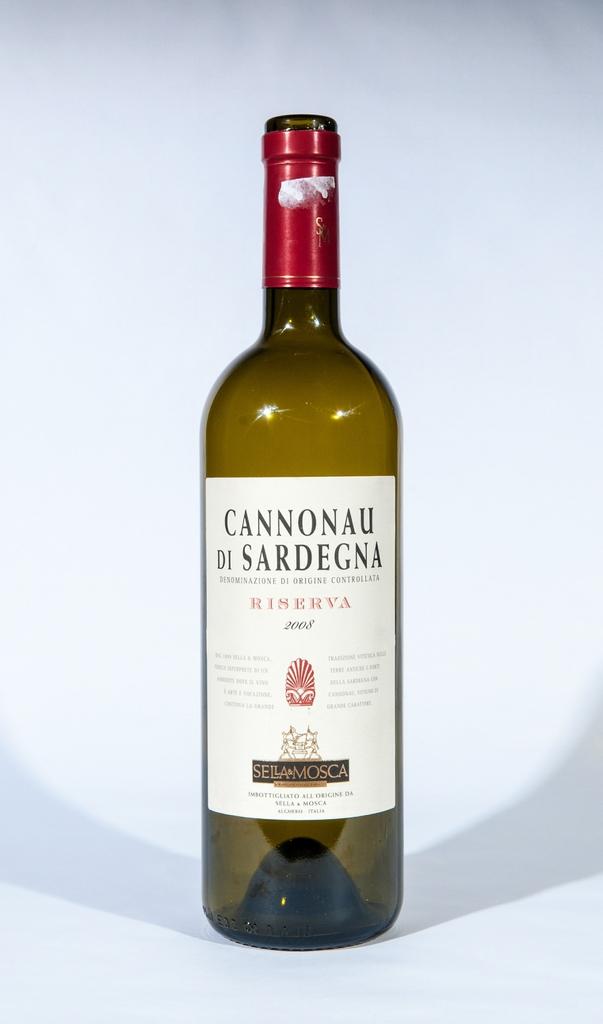What wine is that?
Give a very brief answer. Cannonau di sardegna. Is that a wine?
Make the answer very short. Yes. 